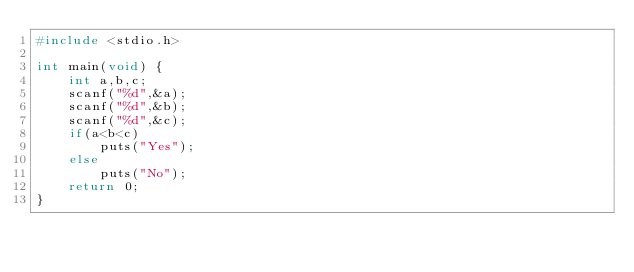<code> <loc_0><loc_0><loc_500><loc_500><_C_>#include <stdio.h>

int main(void) {
	int a,b,c;
	scanf("%d",&a);
	scanf("%d",&b);
	scanf("%d",&c);
	if(a<b<c)
		puts("Yes");
	else
		puts("No");
	return 0;
}
</code> 